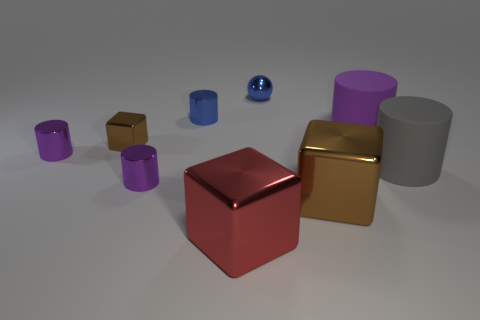Subtract all blue metallic cylinders. How many cylinders are left? 4 Subtract all blue cylinders. How many cylinders are left? 4 Subtract all blue blocks. Subtract all blue spheres. How many blocks are left? 3 Subtract all blue spheres. How many blue blocks are left? 0 Subtract all small things. Subtract all gray rubber cubes. How many objects are left? 4 Add 9 gray matte cylinders. How many gray matte cylinders are left? 10 Add 1 big metal cubes. How many big metal cubes exist? 3 Subtract 0 cyan blocks. How many objects are left? 9 Subtract all spheres. How many objects are left? 8 Subtract 4 cylinders. How many cylinders are left? 1 